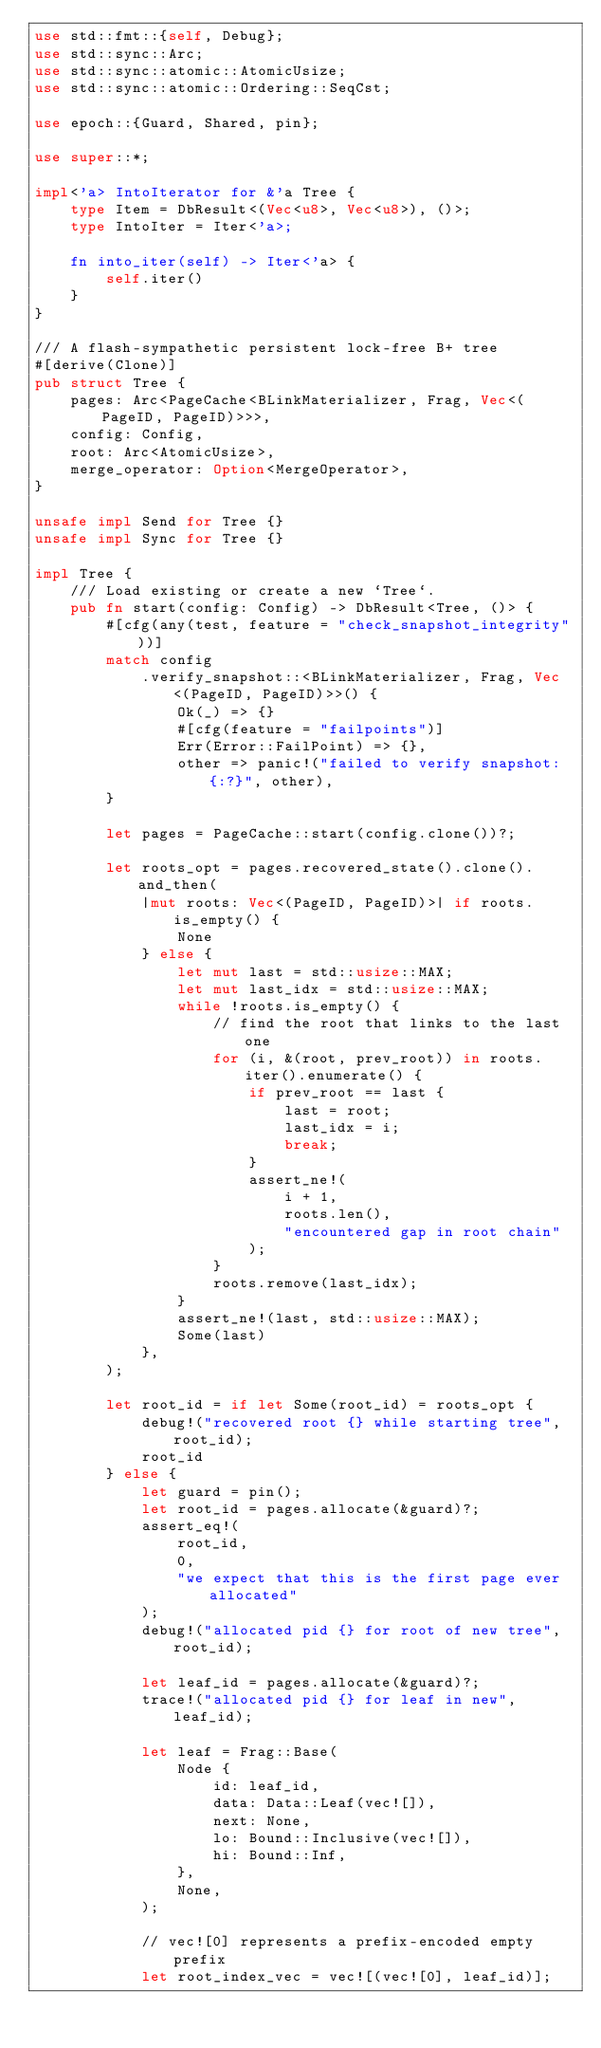Convert code to text. <code><loc_0><loc_0><loc_500><loc_500><_Rust_>use std::fmt::{self, Debug};
use std::sync::Arc;
use std::sync::atomic::AtomicUsize;
use std::sync::atomic::Ordering::SeqCst;

use epoch::{Guard, Shared, pin};

use super::*;

impl<'a> IntoIterator for &'a Tree {
    type Item = DbResult<(Vec<u8>, Vec<u8>), ()>;
    type IntoIter = Iter<'a>;

    fn into_iter(self) -> Iter<'a> {
        self.iter()
    }
}

/// A flash-sympathetic persistent lock-free B+ tree
#[derive(Clone)]
pub struct Tree {
    pages: Arc<PageCache<BLinkMaterializer, Frag, Vec<(PageID, PageID)>>>,
    config: Config,
    root: Arc<AtomicUsize>,
    merge_operator: Option<MergeOperator>,
}

unsafe impl Send for Tree {}
unsafe impl Sync for Tree {}

impl Tree {
    /// Load existing or create a new `Tree`.
    pub fn start(config: Config) -> DbResult<Tree, ()> {
        #[cfg(any(test, feature = "check_snapshot_integrity"))]
        match config
            .verify_snapshot::<BLinkMaterializer, Frag, Vec<(PageID, PageID)>>() {
                Ok(_) => {}
                #[cfg(feature = "failpoints")]
                Err(Error::FailPoint) => {},
                other => panic!("failed to verify snapshot: {:?}", other),
        }

        let pages = PageCache::start(config.clone())?;

        let roots_opt = pages.recovered_state().clone().and_then(
            |mut roots: Vec<(PageID, PageID)>| if roots.is_empty() {
                None
            } else {
                let mut last = std::usize::MAX;
                let mut last_idx = std::usize::MAX;
                while !roots.is_empty() {
                    // find the root that links to the last one
                    for (i, &(root, prev_root)) in roots.iter().enumerate() {
                        if prev_root == last {
                            last = root;
                            last_idx = i;
                            break;
                        }
                        assert_ne!(
                            i + 1,
                            roots.len(),
                            "encountered gap in root chain"
                        );
                    }
                    roots.remove(last_idx);
                }
                assert_ne!(last, std::usize::MAX);
                Some(last)
            },
        );

        let root_id = if let Some(root_id) = roots_opt {
            debug!("recovered root {} while starting tree", root_id);
            root_id
        } else {
            let guard = pin();
            let root_id = pages.allocate(&guard)?;
            assert_eq!(
                root_id,
                0,
                "we expect that this is the first page ever allocated"
            );
            debug!("allocated pid {} for root of new tree", root_id);

            let leaf_id = pages.allocate(&guard)?;
            trace!("allocated pid {} for leaf in new", leaf_id);

            let leaf = Frag::Base(
                Node {
                    id: leaf_id,
                    data: Data::Leaf(vec![]),
                    next: None,
                    lo: Bound::Inclusive(vec![]),
                    hi: Bound::Inf,
                },
                None,
            );

            // vec![0] represents a prefix-encoded empty prefix
            let root_index_vec = vec![(vec![0], leaf_id)];
</code> 